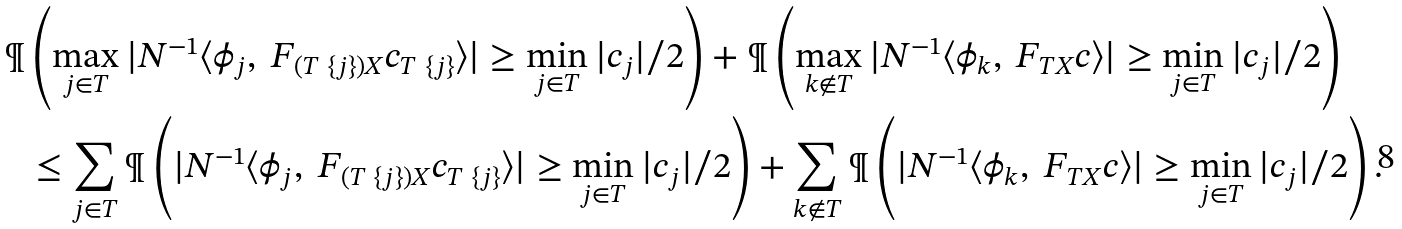Convert formula to latex. <formula><loc_0><loc_0><loc_500><loc_500>\P & \left ( \max _ { j \in T } | N ^ { - 1 } \langle \phi _ { j } , \ F _ { ( T \ \{ j \} ) X } c _ { T \ \{ j \} } \rangle | \geq \min _ { j \in T } | c _ { j } | / 2 \right ) + \P \left ( \max _ { k \notin T } | N ^ { - 1 } \langle \phi _ { k } , \ F _ { T X } c \rangle | \geq \min _ { j \in T } | c _ { j } | / 2 \right ) \\ & \leq \sum _ { j \in T } \P \left ( | N ^ { - 1 } \langle \phi _ { j } , \ F _ { ( T \ \{ j \} ) X } c _ { T \ \{ j \} } \rangle | \geq \min _ { j \in T } | c _ { j } | / 2 \right ) + \sum _ { k \notin T } \P \left ( | N ^ { - 1 } \langle \phi _ { k } , \ F _ { T X } c \rangle | \geq \min _ { j \in T } | c _ { j } | / 2 \right ) .</formula> 